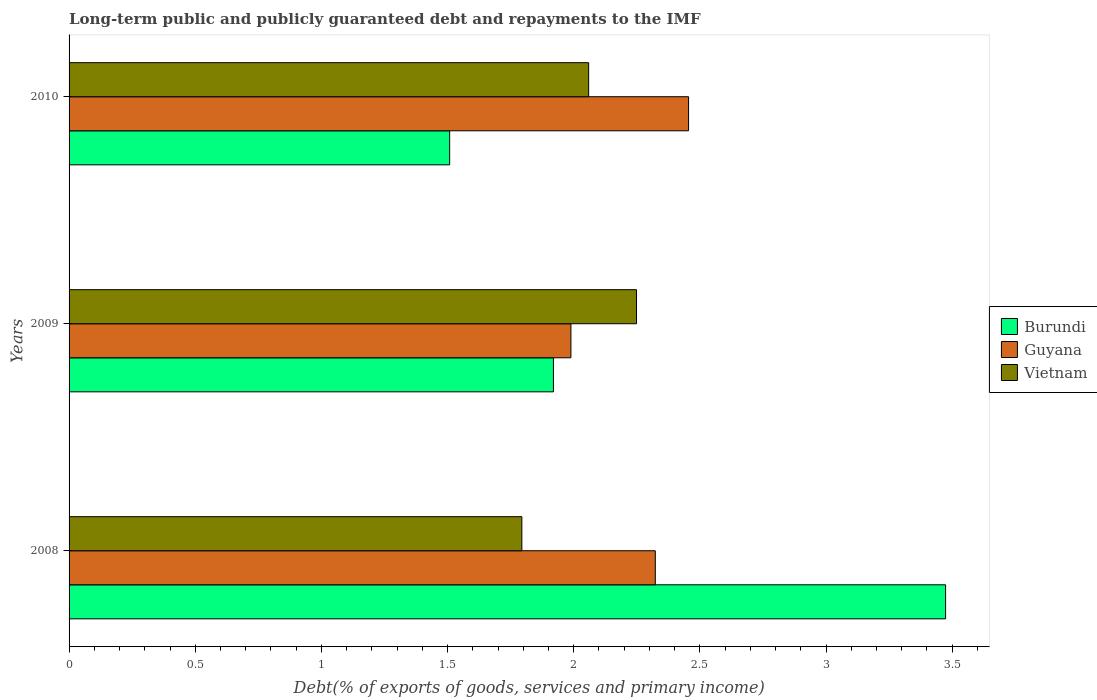Are the number of bars per tick equal to the number of legend labels?
Make the answer very short. Yes. Are the number of bars on each tick of the Y-axis equal?
Provide a short and direct response. Yes. How many bars are there on the 3rd tick from the top?
Provide a short and direct response. 3. How many bars are there on the 2nd tick from the bottom?
Your answer should be compact. 3. In how many cases, is the number of bars for a given year not equal to the number of legend labels?
Offer a terse response. 0. What is the debt and repayments in Vietnam in 2009?
Your answer should be very brief. 2.25. Across all years, what is the maximum debt and repayments in Vietnam?
Provide a short and direct response. 2.25. Across all years, what is the minimum debt and repayments in Burundi?
Offer a very short reply. 1.51. In which year was the debt and repayments in Guyana minimum?
Keep it short and to the point. 2009. What is the total debt and repayments in Guyana in the graph?
Keep it short and to the point. 6.77. What is the difference between the debt and repayments in Guyana in 2008 and that in 2010?
Provide a succinct answer. -0.13. What is the difference between the debt and repayments in Burundi in 2009 and the debt and repayments in Guyana in 2008?
Offer a very short reply. -0.4. What is the average debt and repayments in Guyana per year?
Keep it short and to the point. 2.26. In the year 2010, what is the difference between the debt and repayments in Burundi and debt and repayments in Guyana?
Your answer should be compact. -0.95. What is the ratio of the debt and repayments in Vietnam in 2008 to that in 2009?
Your answer should be compact. 0.8. What is the difference between the highest and the second highest debt and repayments in Burundi?
Your answer should be compact. 1.55. What is the difference between the highest and the lowest debt and repayments in Guyana?
Your answer should be compact. 0.47. In how many years, is the debt and repayments in Burundi greater than the average debt and repayments in Burundi taken over all years?
Offer a very short reply. 1. Is the sum of the debt and repayments in Vietnam in 2009 and 2010 greater than the maximum debt and repayments in Burundi across all years?
Give a very brief answer. Yes. What does the 3rd bar from the top in 2009 represents?
Provide a short and direct response. Burundi. What does the 1st bar from the bottom in 2010 represents?
Keep it short and to the point. Burundi. How many bars are there?
Make the answer very short. 9. Are all the bars in the graph horizontal?
Your answer should be compact. Yes. How many years are there in the graph?
Your answer should be very brief. 3. Are the values on the major ticks of X-axis written in scientific E-notation?
Offer a terse response. No. Does the graph contain grids?
Ensure brevity in your answer.  No. Where does the legend appear in the graph?
Provide a succinct answer. Center right. How many legend labels are there?
Make the answer very short. 3. How are the legend labels stacked?
Ensure brevity in your answer.  Vertical. What is the title of the graph?
Your response must be concise. Long-term public and publicly guaranteed debt and repayments to the IMF. Does "Upper middle income" appear as one of the legend labels in the graph?
Provide a succinct answer. No. What is the label or title of the X-axis?
Keep it short and to the point. Debt(% of exports of goods, services and primary income). What is the Debt(% of exports of goods, services and primary income) of Burundi in 2008?
Your response must be concise. 3.47. What is the Debt(% of exports of goods, services and primary income) in Guyana in 2008?
Keep it short and to the point. 2.32. What is the Debt(% of exports of goods, services and primary income) in Vietnam in 2008?
Keep it short and to the point. 1.79. What is the Debt(% of exports of goods, services and primary income) of Burundi in 2009?
Offer a very short reply. 1.92. What is the Debt(% of exports of goods, services and primary income) of Guyana in 2009?
Offer a terse response. 1.99. What is the Debt(% of exports of goods, services and primary income) of Vietnam in 2009?
Make the answer very short. 2.25. What is the Debt(% of exports of goods, services and primary income) of Burundi in 2010?
Your response must be concise. 1.51. What is the Debt(% of exports of goods, services and primary income) of Guyana in 2010?
Make the answer very short. 2.46. What is the Debt(% of exports of goods, services and primary income) of Vietnam in 2010?
Ensure brevity in your answer.  2.06. Across all years, what is the maximum Debt(% of exports of goods, services and primary income) of Burundi?
Make the answer very short. 3.47. Across all years, what is the maximum Debt(% of exports of goods, services and primary income) of Guyana?
Ensure brevity in your answer.  2.46. Across all years, what is the maximum Debt(% of exports of goods, services and primary income) in Vietnam?
Your answer should be compact. 2.25. Across all years, what is the minimum Debt(% of exports of goods, services and primary income) in Burundi?
Your answer should be compact. 1.51. Across all years, what is the minimum Debt(% of exports of goods, services and primary income) of Guyana?
Give a very brief answer. 1.99. Across all years, what is the minimum Debt(% of exports of goods, services and primary income) in Vietnam?
Your answer should be very brief. 1.79. What is the total Debt(% of exports of goods, services and primary income) in Burundi in the graph?
Your answer should be compact. 6.9. What is the total Debt(% of exports of goods, services and primary income) of Guyana in the graph?
Keep it short and to the point. 6.77. What is the total Debt(% of exports of goods, services and primary income) in Vietnam in the graph?
Keep it short and to the point. 6.1. What is the difference between the Debt(% of exports of goods, services and primary income) in Burundi in 2008 and that in 2009?
Offer a very short reply. 1.55. What is the difference between the Debt(% of exports of goods, services and primary income) in Guyana in 2008 and that in 2009?
Ensure brevity in your answer.  0.33. What is the difference between the Debt(% of exports of goods, services and primary income) in Vietnam in 2008 and that in 2009?
Offer a terse response. -0.45. What is the difference between the Debt(% of exports of goods, services and primary income) in Burundi in 2008 and that in 2010?
Offer a very short reply. 1.97. What is the difference between the Debt(% of exports of goods, services and primary income) of Guyana in 2008 and that in 2010?
Ensure brevity in your answer.  -0.13. What is the difference between the Debt(% of exports of goods, services and primary income) in Vietnam in 2008 and that in 2010?
Offer a very short reply. -0.26. What is the difference between the Debt(% of exports of goods, services and primary income) of Burundi in 2009 and that in 2010?
Ensure brevity in your answer.  0.41. What is the difference between the Debt(% of exports of goods, services and primary income) in Guyana in 2009 and that in 2010?
Keep it short and to the point. -0.47. What is the difference between the Debt(% of exports of goods, services and primary income) in Vietnam in 2009 and that in 2010?
Make the answer very short. 0.19. What is the difference between the Debt(% of exports of goods, services and primary income) in Burundi in 2008 and the Debt(% of exports of goods, services and primary income) in Guyana in 2009?
Give a very brief answer. 1.49. What is the difference between the Debt(% of exports of goods, services and primary income) in Burundi in 2008 and the Debt(% of exports of goods, services and primary income) in Vietnam in 2009?
Offer a very short reply. 1.22. What is the difference between the Debt(% of exports of goods, services and primary income) in Guyana in 2008 and the Debt(% of exports of goods, services and primary income) in Vietnam in 2009?
Provide a short and direct response. 0.07. What is the difference between the Debt(% of exports of goods, services and primary income) of Burundi in 2008 and the Debt(% of exports of goods, services and primary income) of Guyana in 2010?
Offer a terse response. 1.02. What is the difference between the Debt(% of exports of goods, services and primary income) of Burundi in 2008 and the Debt(% of exports of goods, services and primary income) of Vietnam in 2010?
Make the answer very short. 1.41. What is the difference between the Debt(% of exports of goods, services and primary income) of Guyana in 2008 and the Debt(% of exports of goods, services and primary income) of Vietnam in 2010?
Your answer should be very brief. 0.26. What is the difference between the Debt(% of exports of goods, services and primary income) in Burundi in 2009 and the Debt(% of exports of goods, services and primary income) in Guyana in 2010?
Make the answer very short. -0.54. What is the difference between the Debt(% of exports of goods, services and primary income) in Burundi in 2009 and the Debt(% of exports of goods, services and primary income) in Vietnam in 2010?
Provide a succinct answer. -0.14. What is the difference between the Debt(% of exports of goods, services and primary income) of Guyana in 2009 and the Debt(% of exports of goods, services and primary income) of Vietnam in 2010?
Offer a very short reply. -0.07. What is the average Debt(% of exports of goods, services and primary income) of Burundi per year?
Make the answer very short. 2.3. What is the average Debt(% of exports of goods, services and primary income) of Guyana per year?
Your answer should be compact. 2.26. What is the average Debt(% of exports of goods, services and primary income) in Vietnam per year?
Make the answer very short. 2.03. In the year 2008, what is the difference between the Debt(% of exports of goods, services and primary income) of Burundi and Debt(% of exports of goods, services and primary income) of Guyana?
Ensure brevity in your answer.  1.15. In the year 2008, what is the difference between the Debt(% of exports of goods, services and primary income) of Burundi and Debt(% of exports of goods, services and primary income) of Vietnam?
Keep it short and to the point. 1.68. In the year 2008, what is the difference between the Debt(% of exports of goods, services and primary income) in Guyana and Debt(% of exports of goods, services and primary income) in Vietnam?
Make the answer very short. 0.53. In the year 2009, what is the difference between the Debt(% of exports of goods, services and primary income) in Burundi and Debt(% of exports of goods, services and primary income) in Guyana?
Your response must be concise. -0.07. In the year 2009, what is the difference between the Debt(% of exports of goods, services and primary income) of Burundi and Debt(% of exports of goods, services and primary income) of Vietnam?
Provide a succinct answer. -0.33. In the year 2009, what is the difference between the Debt(% of exports of goods, services and primary income) in Guyana and Debt(% of exports of goods, services and primary income) in Vietnam?
Make the answer very short. -0.26. In the year 2010, what is the difference between the Debt(% of exports of goods, services and primary income) in Burundi and Debt(% of exports of goods, services and primary income) in Guyana?
Offer a terse response. -0.95. In the year 2010, what is the difference between the Debt(% of exports of goods, services and primary income) in Burundi and Debt(% of exports of goods, services and primary income) in Vietnam?
Provide a succinct answer. -0.55. In the year 2010, what is the difference between the Debt(% of exports of goods, services and primary income) of Guyana and Debt(% of exports of goods, services and primary income) of Vietnam?
Your response must be concise. 0.4. What is the ratio of the Debt(% of exports of goods, services and primary income) of Burundi in 2008 to that in 2009?
Offer a very short reply. 1.81. What is the ratio of the Debt(% of exports of goods, services and primary income) of Guyana in 2008 to that in 2009?
Offer a terse response. 1.17. What is the ratio of the Debt(% of exports of goods, services and primary income) in Vietnam in 2008 to that in 2009?
Offer a very short reply. 0.8. What is the ratio of the Debt(% of exports of goods, services and primary income) in Burundi in 2008 to that in 2010?
Provide a succinct answer. 2.3. What is the ratio of the Debt(% of exports of goods, services and primary income) in Guyana in 2008 to that in 2010?
Provide a succinct answer. 0.95. What is the ratio of the Debt(% of exports of goods, services and primary income) in Vietnam in 2008 to that in 2010?
Ensure brevity in your answer.  0.87. What is the ratio of the Debt(% of exports of goods, services and primary income) in Burundi in 2009 to that in 2010?
Your response must be concise. 1.27. What is the ratio of the Debt(% of exports of goods, services and primary income) of Guyana in 2009 to that in 2010?
Give a very brief answer. 0.81. What is the ratio of the Debt(% of exports of goods, services and primary income) in Vietnam in 2009 to that in 2010?
Ensure brevity in your answer.  1.09. What is the difference between the highest and the second highest Debt(% of exports of goods, services and primary income) in Burundi?
Your answer should be very brief. 1.55. What is the difference between the highest and the second highest Debt(% of exports of goods, services and primary income) of Guyana?
Make the answer very short. 0.13. What is the difference between the highest and the second highest Debt(% of exports of goods, services and primary income) in Vietnam?
Offer a terse response. 0.19. What is the difference between the highest and the lowest Debt(% of exports of goods, services and primary income) in Burundi?
Your answer should be compact. 1.97. What is the difference between the highest and the lowest Debt(% of exports of goods, services and primary income) in Guyana?
Ensure brevity in your answer.  0.47. What is the difference between the highest and the lowest Debt(% of exports of goods, services and primary income) of Vietnam?
Keep it short and to the point. 0.45. 